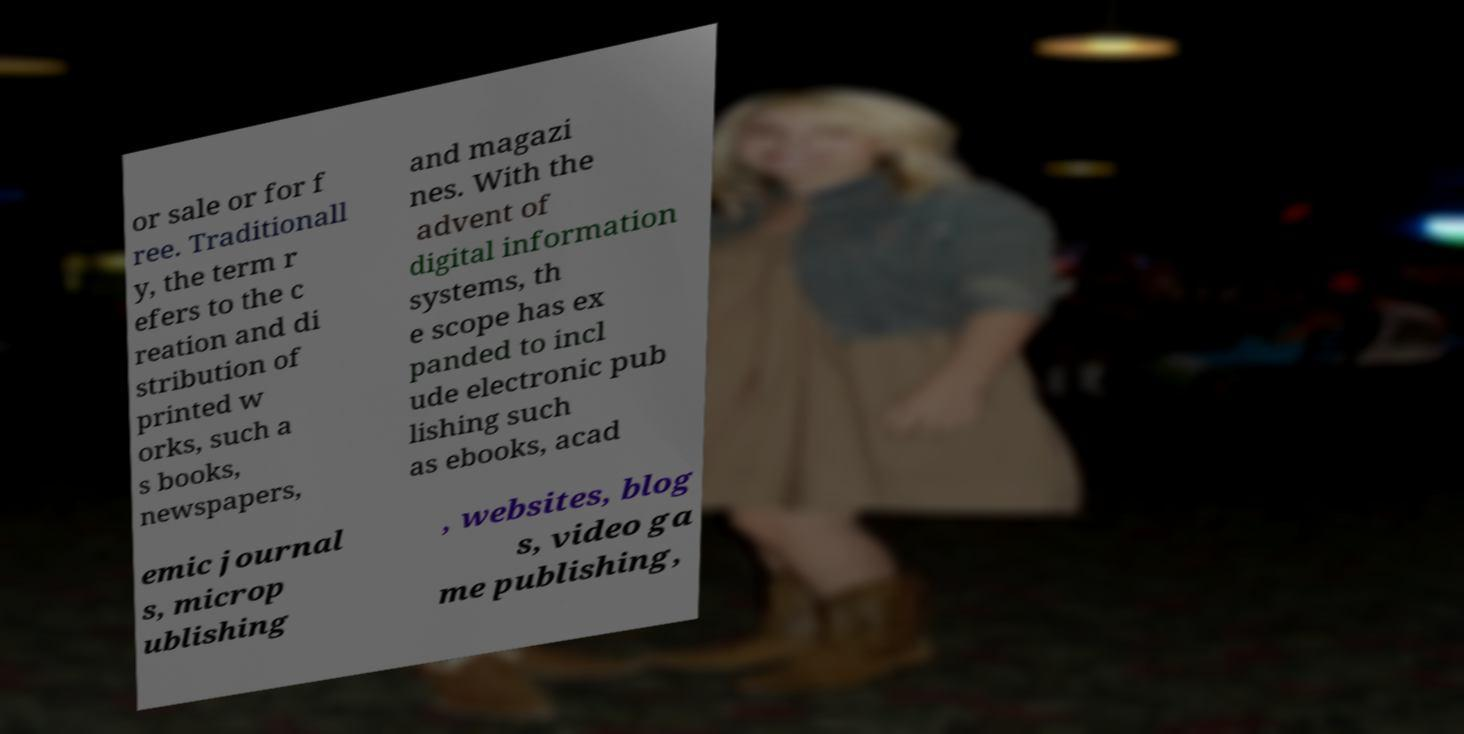For documentation purposes, I need the text within this image transcribed. Could you provide that? or sale or for f ree. Traditionall y, the term r efers to the c reation and di stribution of printed w orks, such a s books, newspapers, and magazi nes. With the advent of digital information systems, th e scope has ex panded to incl ude electronic pub lishing such as ebooks, acad emic journal s, microp ublishing , websites, blog s, video ga me publishing, 